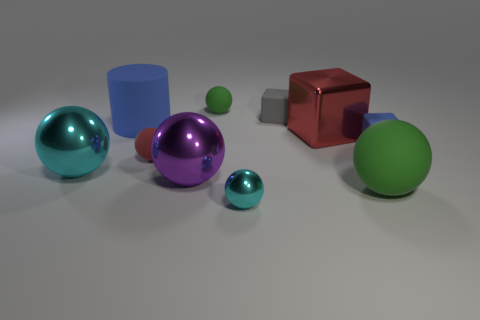The large green object that is the same material as the tiny gray cube is what shape?
Make the answer very short. Sphere. Is the size of the purple shiny sphere in front of the red rubber object the same as the cyan ball that is on the right side of the large purple sphere?
Your response must be concise. No. What is the color of the ball that is in front of the large green thing?
Your response must be concise. Cyan. What is the cyan thing that is in front of the cyan shiny thing that is behind the purple metallic ball made of?
Offer a terse response. Metal. The purple object has what shape?
Your answer should be very brief. Sphere. There is a large purple object that is the same shape as the big green object; what is it made of?
Your response must be concise. Metal. What number of blue cylinders are the same size as the purple ball?
Provide a short and direct response. 1. Are there any cylinders that are in front of the green rubber sphere in front of the big red shiny block?
Your answer should be very brief. No. How many gray things are tiny matte blocks or matte balls?
Provide a succinct answer. 1. What is the color of the tiny shiny sphere?
Offer a terse response. Cyan. 